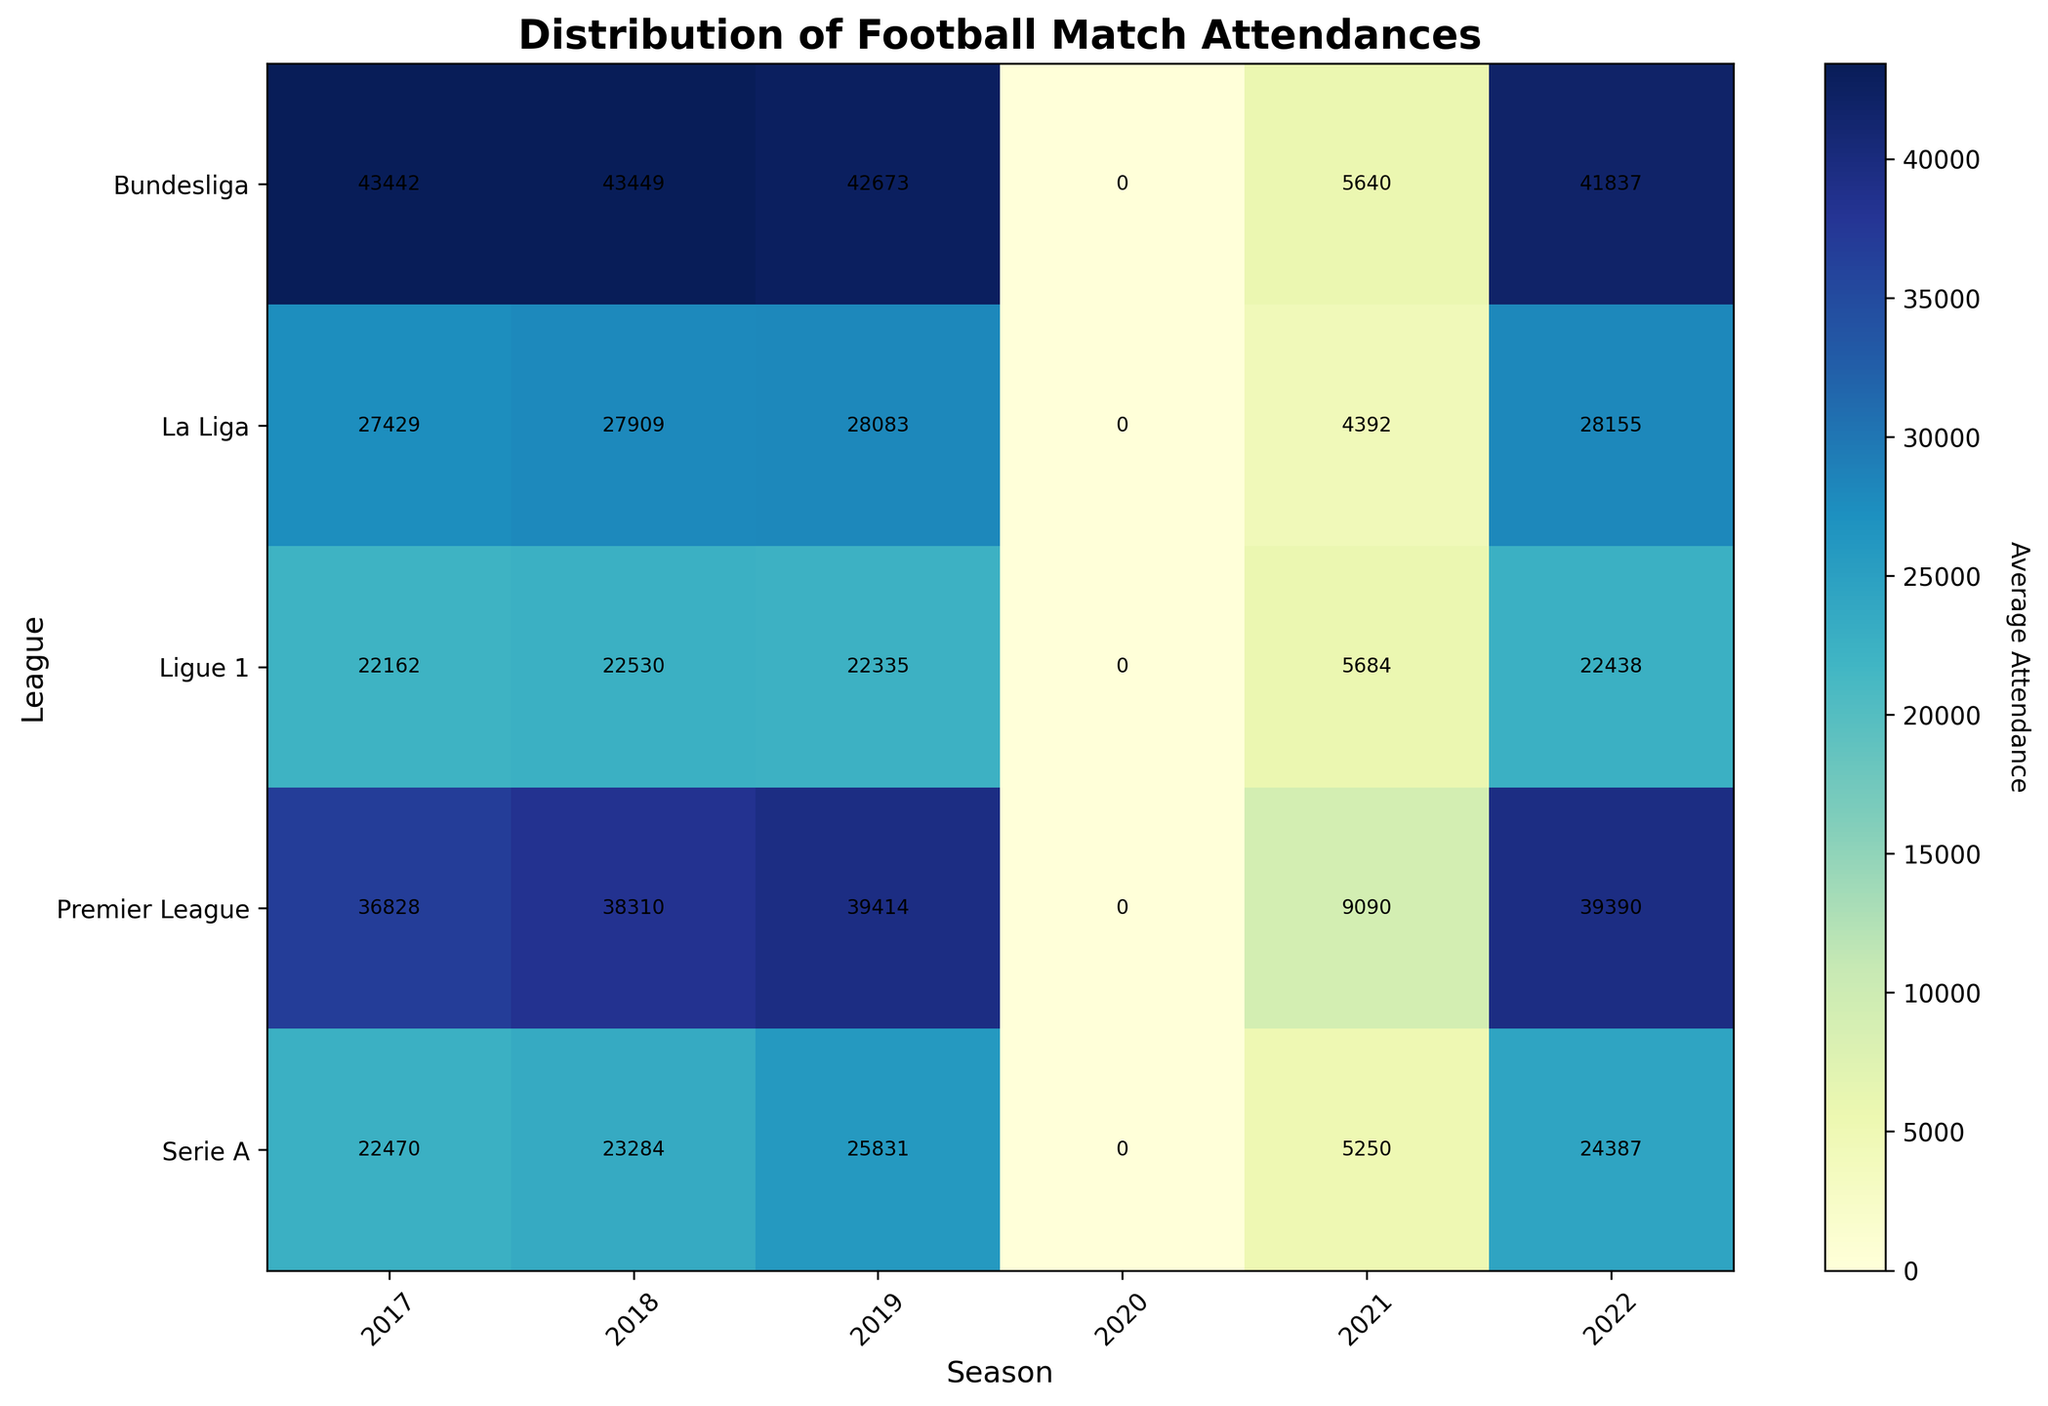Which league had the highest average attendance in 2019? To find the league with the highest average attendance in 2019, look at the column labeled "2019" and identify the cell with the maximum value.
Answer: Bundesliga How did the average attendance in the Premier League change from 2017 to 2018? Compare the values in the "Premier League" row for the years 2017 and 2018. The average attendance increased from 36,828 to 38,310. Calculate the difference: 38,310 - 36,828 = 1,482.
Answer: Increased by 1,482 Which league saw the biggest drop in average attendance between 2019 and 2020? Identify the values in the "2019" and "2020" columns for each league. Note that all leagues have an average attendance of 0 in 2020 due to the circumstances, making this a uniform drop across leagues.
Answer: All leagues dropped to 0 What was the average attendance in La Liga in 2021? Look at the value in the "La Liga" row for the year 2021. The average attendance for La Liga in 2021 was 4,392.
Answer: 4,392 Which leagues have regained their average attendance to about pre-2020 levels by 2022? Compare the values for 2019 and 2022 for each league. Both Premier League (39,414 in 2019 and 39,390 in 2022) and La Liga (28,083 in 2019 and 28,155 in 2022) have nearly regained their pre-2020 levels.
Answer: Premier League, La Liga From which season did all leagues experience a significant drop in average attendance? Examine the figure and note when the average attendance dropped to 0 across all leagues. This occurred in the season labeled "2020."
Answer: 2020 What was the approximate range of average attendances in Ligue 1 over the given seasons? Identify the minimum and maximum values for "Ligue 1" across the seasons. The values range from 5,684 in 2021 to 22,530 in 2018.
Answer: 5,684 to 22,530 How does the color intensity differ for Bundesliga compared to Serie A in 2018? Notice the color on the heatmap for Bundesliga and Serie A in the column labeled "2018." Bundesliga has a darker color, indicating higher attendance compared to Serie A.
Answer: Bundesliga is darker/higher What was the combined average attendance for Serie A and Ligue 1 in 2022? Add the values for Serie A (24,387) and Ligue 1 (22,438) in 2022. 24,387 + 22,438 = 46,825.
Answer: 46,825 